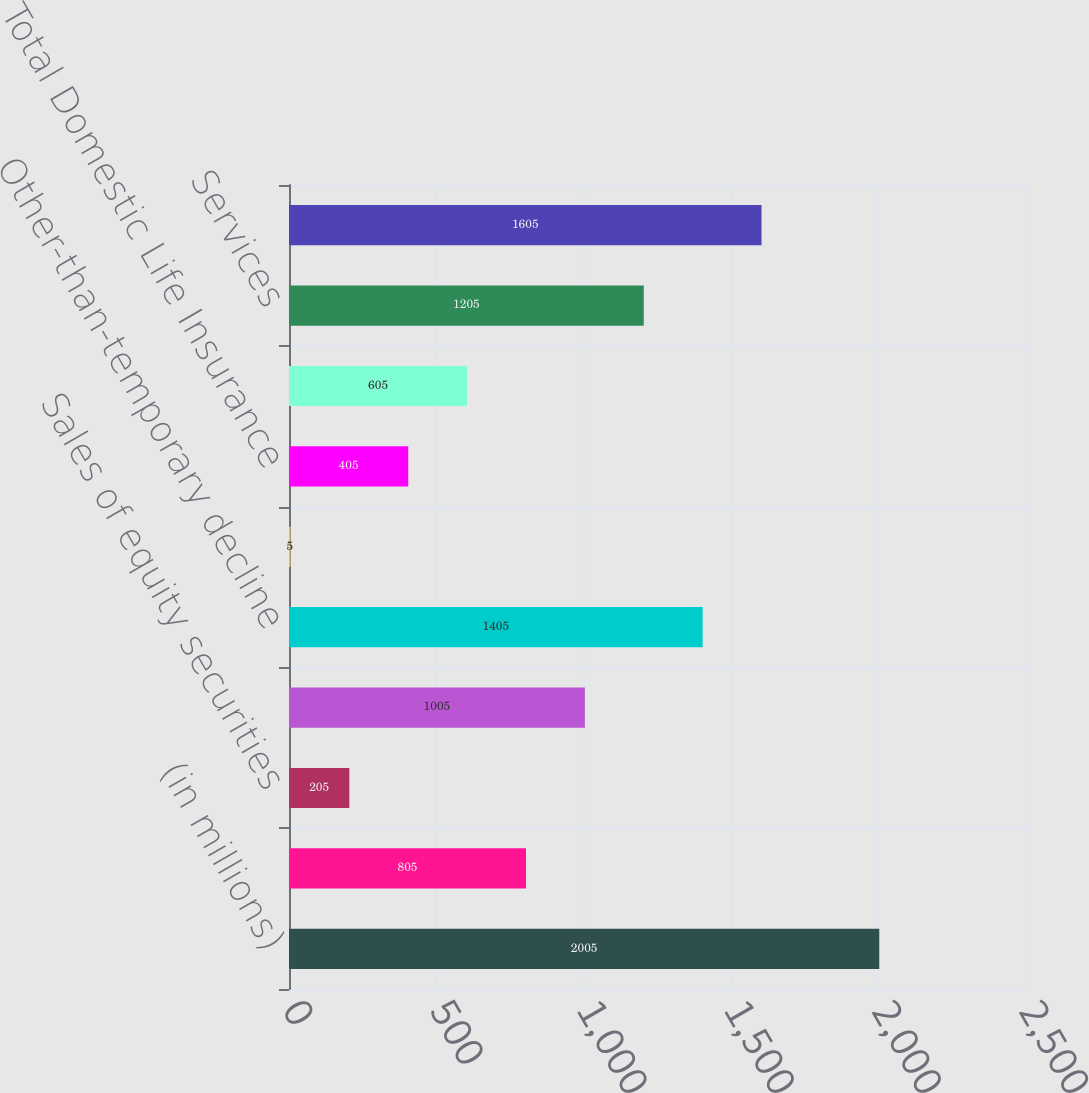Convert chart to OTSL. <chart><loc_0><loc_0><loc_500><loc_500><bar_chart><fcel>(in millions)<fcel>Sales of fixed maturities<fcel>Sales of equity securities<fcel>Derivatives instruments<fcel>Other-than-temporary decline<fcel>Other<fcel>Total Domestic Life Insurance<fcel>Foreign exchange transactions<fcel>Services<fcel>Total<nl><fcel>2005<fcel>805<fcel>205<fcel>1005<fcel>1405<fcel>5<fcel>405<fcel>605<fcel>1205<fcel>1605<nl></chart> 